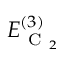Convert formula to latex. <formula><loc_0><loc_0><loc_500><loc_500>E _ { C _ { 2 } } ^ { ( 3 ) }</formula> 